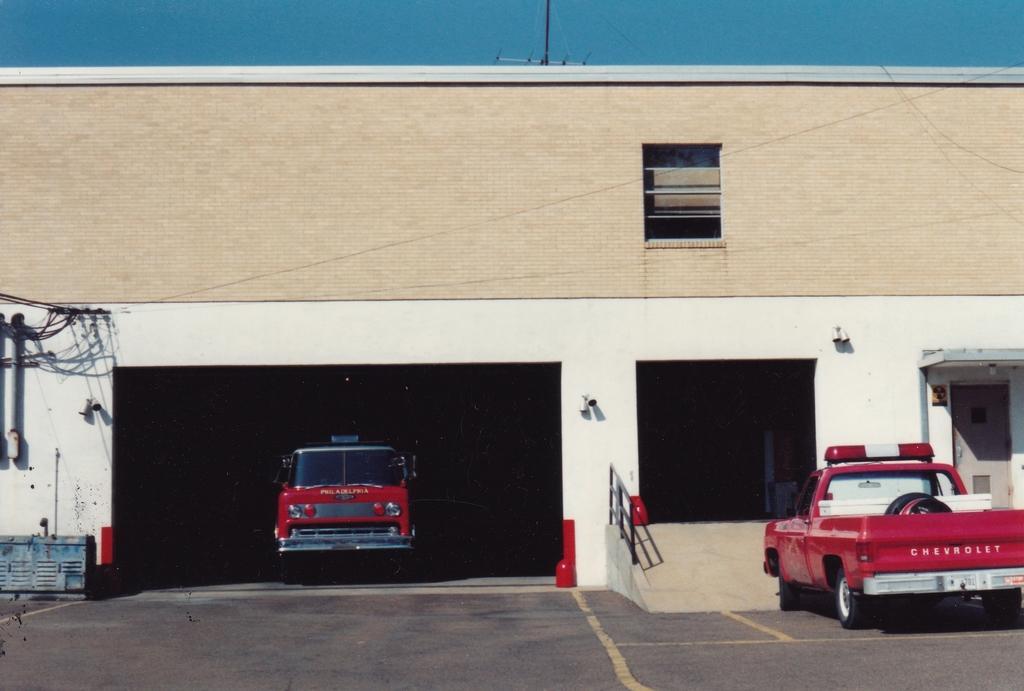How would you summarize this image in a sentence or two? In the center of the image there is a building. At the bottom we can see vehicles on the road. At the top there is sky. 